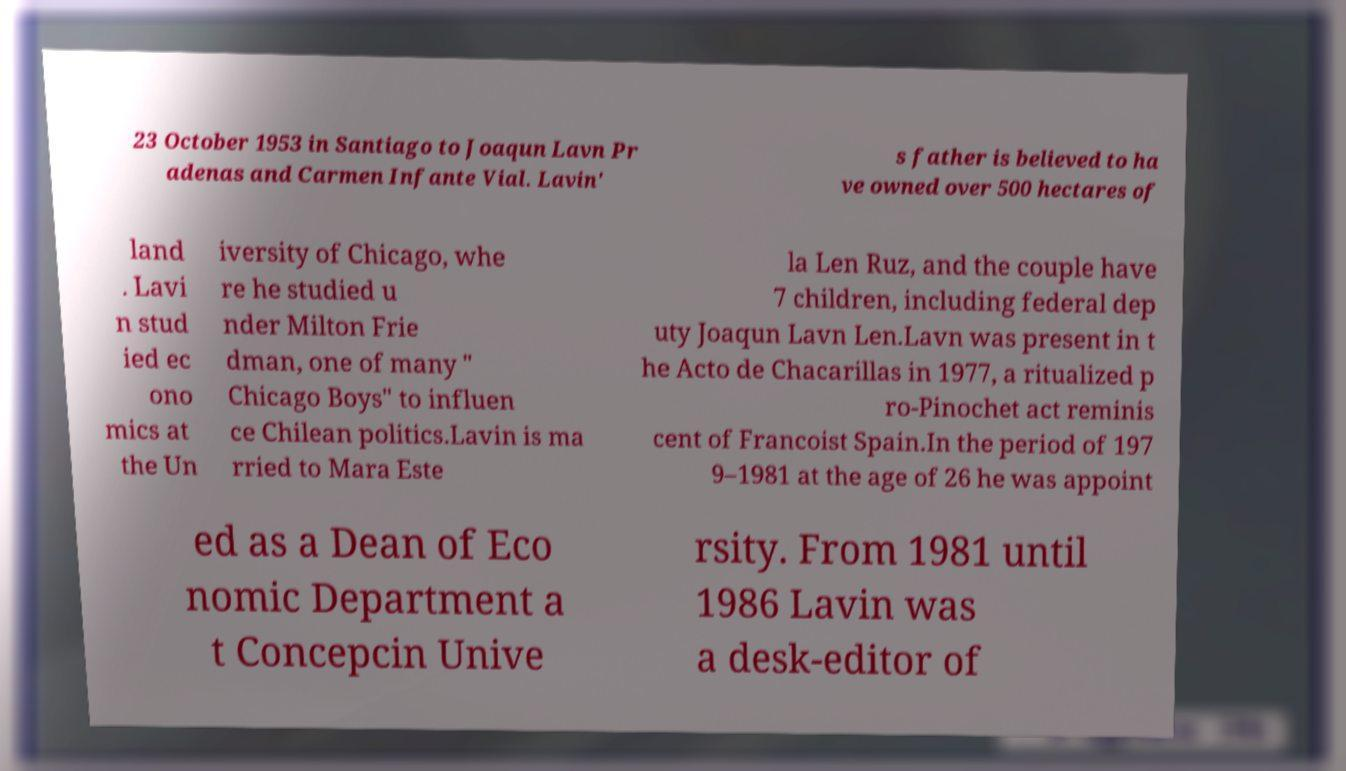Please identify and transcribe the text found in this image. 23 October 1953 in Santiago to Joaqun Lavn Pr adenas and Carmen Infante Vial. Lavin' s father is believed to ha ve owned over 500 hectares of land . Lavi n stud ied ec ono mics at the Un iversity of Chicago, whe re he studied u nder Milton Frie dman, one of many " Chicago Boys" to influen ce Chilean politics.Lavin is ma rried to Mara Este la Len Ruz, and the couple have 7 children, including federal dep uty Joaqun Lavn Len.Lavn was present in t he Acto de Chacarillas in 1977, a ritualized p ro-Pinochet act reminis cent of Francoist Spain.In the period of 197 9–1981 at the age of 26 he was appoint ed as a Dean of Eco nomic Department a t Concepcin Unive rsity. From 1981 until 1986 Lavin was a desk-editor of 